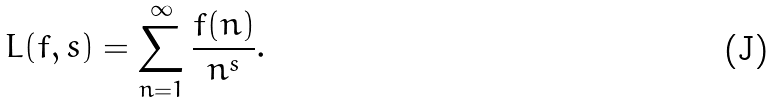<formula> <loc_0><loc_0><loc_500><loc_500>L ( f , s ) = \sum _ { n = 1 } ^ { \infty } \frac { f ( n ) } { n ^ { s } } .</formula> 